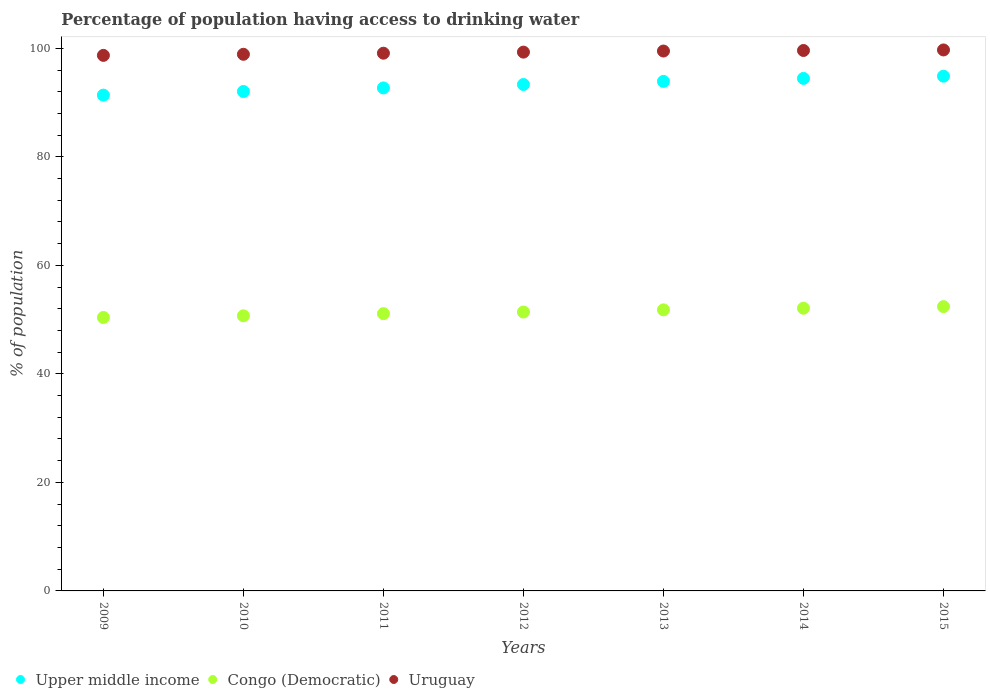How many different coloured dotlines are there?
Provide a short and direct response. 3. Is the number of dotlines equal to the number of legend labels?
Provide a short and direct response. Yes. What is the percentage of population having access to drinking water in Congo (Democratic) in 2009?
Your response must be concise. 50.4. Across all years, what is the maximum percentage of population having access to drinking water in Uruguay?
Make the answer very short. 99.7. Across all years, what is the minimum percentage of population having access to drinking water in Congo (Democratic)?
Offer a very short reply. 50.4. In which year was the percentage of population having access to drinking water in Upper middle income maximum?
Ensure brevity in your answer.  2015. In which year was the percentage of population having access to drinking water in Uruguay minimum?
Provide a succinct answer. 2009. What is the total percentage of population having access to drinking water in Congo (Democratic) in the graph?
Ensure brevity in your answer.  359.9. What is the difference between the percentage of population having access to drinking water in Congo (Democratic) in 2009 and that in 2013?
Give a very brief answer. -1.4. What is the difference between the percentage of population having access to drinking water in Congo (Democratic) in 2012 and the percentage of population having access to drinking water in Uruguay in 2009?
Ensure brevity in your answer.  -47.3. What is the average percentage of population having access to drinking water in Congo (Democratic) per year?
Provide a succinct answer. 51.41. In the year 2015, what is the difference between the percentage of population having access to drinking water in Uruguay and percentage of population having access to drinking water in Congo (Democratic)?
Provide a succinct answer. 47.3. What is the ratio of the percentage of population having access to drinking water in Uruguay in 2013 to that in 2014?
Give a very brief answer. 1. Is the percentage of population having access to drinking water in Upper middle income in 2011 less than that in 2015?
Make the answer very short. Yes. Is the difference between the percentage of population having access to drinking water in Uruguay in 2010 and 2015 greater than the difference between the percentage of population having access to drinking water in Congo (Democratic) in 2010 and 2015?
Offer a terse response. Yes. What is the difference between the highest and the second highest percentage of population having access to drinking water in Upper middle income?
Give a very brief answer. 0.41. What is the difference between the highest and the lowest percentage of population having access to drinking water in Congo (Democratic)?
Your answer should be compact. 2. In how many years, is the percentage of population having access to drinking water in Upper middle income greater than the average percentage of population having access to drinking water in Upper middle income taken over all years?
Provide a succinct answer. 4. Is it the case that in every year, the sum of the percentage of population having access to drinking water in Upper middle income and percentage of population having access to drinking water in Uruguay  is greater than the percentage of population having access to drinking water in Congo (Democratic)?
Your response must be concise. Yes. Is the percentage of population having access to drinking water in Upper middle income strictly greater than the percentage of population having access to drinking water in Congo (Democratic) over the years?
Keep it short and to the point. Yes. How many dotlines are there?
Your answer should be compact. 3. How many years are there in the graph?
Make the answer very short. 7. Are the values on the major ticks of Y-axis written in scientific E-notation?
Keep it short and to the point. No. How are the legend labels stacked?
Ensure brevity in your answer.  Horizontal. What is the title of the graph?
Ensure brevity in your answer.  Percentage of population having access to drinking water. Does "Paraguay" appear as one of the legend labels in the graph?
Your answer should be compact. No. What is the label or title of the Y-axis?
Your answer should be compact. % of population. What is the % of population of Upper middle income in 2009?
Provide a short and direct response. 91.38. What is the % of population of Congo (Democratic) in 2009?
Make the answer very short. 50.4. What is the % of population in Uruguay in 2009?
Make the answer very short. 98.7. What is the % of population in Upper middle income in 2010?
Provide a succinct answer. 92.04. What is the % of population in Congo (Democratic) in 2010?
Give a very brief answer. 50.7. What is the % of population of Uruguay in 2010?
Offer a very short reply. 98.9. What is the % of population in Upper middle income in 2011?
Ensure brevity in your answer.  92.7. What is the % of population in Congo (Democratic) in 2011?
Give a very brief answer. 51.1. What is the % of population of Uruguay in 2011?
Your answer should be very brief. 99.1. What is the % of population of Upper middle income in 2012?
Provide a short and direct response. 93.33. What is the % of population in Congo (Democratic) in 2012?
Ensure brevity in your answer.  51.4. What is the % of population of Uruguay in 2012?
Provide a succinct answer. 99.3. What is the % of population of Upper middle income in 2013?
Give a very brief answer. 93.91. What is the % of population in Congo (Democratic) in 2013?
Your response must be concise. 51.8. What is the % of population of Uruguay in 2013?
Provide a short and direct response. 99.5. What is the % of population in Upper middle income in 2014?
Make the answer very short. 94.45. What is the % of population in Congo (Democratic) in 2014?
Ensure brevity in your answer.  52.1. What is the % of population of Uruguay in 2014?
Give a very brief answer. 99.6. What is the % of population in Upper middle income in 2015?
Ensure brevity in your answer.  94.87. What is the % of population of Congo (Democratic) in 2015?
Offer a terse response. 52.4. What is the % of population in Uruguay in 2015?
Your answer should be compact. 99.7. Across all years, what is the maximum % of population in Upper middle income?
Your answer should be very brief. 94.87. Across all years, what is the maximum % of population in Congo (Democratic)?
Provide a short and direct response. 52.4. Across all years, what is the maximum % of population of Uruguay?
Offer a terse response. 99.7. Across all years, what is the minimum % of population in Upper middle income?
Provide a succinct answer. 91.38. Across all years, what is the minimum % of population in Congo (Democratic)?
Provide a short and direct response. 50.4. Across all years, what is the minimum % of population in Uruguay?
Your response must be concise. 98.7. What is the total % of population in Upper middle income in the graph?
Offer a very short reply. 652.68. What is the total % of population of Congo (Democratic) in the graph?
Offer a terse response. 359.9. What is the total % of population in Uruguay in the graph?
Your answer should be compact. 694.8. What is the difference between the % of population of Upper middle income in 2009 and that in 2010?
Provide a short and direct response. -0.67. What is the difference between the % of population of Upper middle income in 2009 and that in 2011?
Offer a very short reply. -1.32. What is the difference between the % of population of Upper middle income in 2009 and that in 2012?
Offer a terse response. -1.96. What is the difference between the % of population in Uruguay in 2009 and that in 2012?
Keep it short and to the point. -0.6. What is the difference between the % of population in Upper middle income in 2009 and that in 2013?
Ensure brevity in your answer.  -2.53. What is the difference between the % of population of Congo (Democratic) in 2009 and that in 2013?
Provide a succinct answer. -1.4. What is the difference between the % of population of Uruguay in 2009 and that in 2013?
Keep it short and to the point. -0.8. What is the difference between the % of population in Upper middle income in 2009 and that in 2014?
Your response must be concise. -3.08. What is the difference between the % of population of Upper middle income in 2009 and that in 2015?
Your response must be concise. -3.49. What is the difference between the % of population in Upper middle income in 2010 and that in 2011?
Your answer should be compact. -0.65. What is the difference between the % of population of Congo (Democratic) in 2010 and that in 2011?
Your answer should be very brief. -0.4. What is the difference between the % of population of Uruguay in 2010 and that in 2011?
Offer a very short reply. -0.2. What is the difference between the % of population of Upper middle income in 2010 and that in 2012?
Provide a short and direct response. -1.29. What is the difference between the % of population in Congo (Democratic) in 2010 and that in 2012?
Your answer should be very brief. -0.7. What is the difference between the % of population of Upper middle income in 2010 and that in 2013?
Offer a terse response. -1.86. What is the difference between the % of population of Upper middle income in 2010 and that in 2014?
Your answer should be compact. -2.41. What is the difference between the % of population in Upper middle income in 2010 and that in 2015?
Your response must be concise. -2.82. What is the difference between the % of population of Upper middle income in 2011 and that in 2012?
Provide a short and direct response. -0.64. What is the difference between the % of population in Congo (Democratic) in 2011 and that in 2012?
Keep it short and to the point. -0.3. What is the difference between the % of population in Upper middle income in 2011 and that in 2013?
Make the answer very short. -1.21. What is the difference between the % of population in Congo (Democratic) in 2011 and that in 2013?
Offer a terse response. -0.7. What is the difference between the % of population in Uruguay in 2011 and that in 2013?
Provide a short and direct response. -0.4. What is the difference between the % of population in Upper middle income in 2011 and that in 2014?
Offer a terse response. -1.76. What is the difference between the % of population in Uruguay in 2011 and that in 2014?
Offer a very short reply. -0.5. What is the difference between the % of population of Upper middle income in 2011 and that in 2015?
Offer a very short reply. -2.17. What is the difference between the % of population of Congo (Democratic) in 2011 and that in 2015?
Offer a terse response. -1.3. What is the difference between the % of population of Uruguay in 2011 and that in 2015?
Keep it short and to the point. -0.6. What is the difference between the % of population in Upper middle income in 2012 and that in 2013?
Keep it short and to the point. -0.57. What is the difference between the % of population of Congo (Democratic) in 2012 and that in 2013?
Your response must be concise. -0.4. What is the difference between the % of population in Uruguay in 2012 and that in 2013?
Offer a very short reply. -0.2. What is the difference between the % of population of Upper middle income in 2012 and that in 2014?
Offer a very short reply. -1.12. What is the difference between the % of population of Uruguay in 2012 and that in 2014?
Offer a very short reply. -0.3. What is the difference between the % of population in Upper middle income in 2012 and that in 2015?
Offer a very short reply. -1.53. What is the difference between the % of population in Congo (Democratic) in 2012 and that in 2015?
Give a very brief answer. -1. What is the difference between the % of population in Upper middle income in 2013 and that in 2014?
Keep it short and to the point. -0.55. What is the difference between the % of population of Upper middle income in 2013 and that in 2015?
Provide a short and direct response. -0.96. What is the difference between the % of population in Congo (Democratic) in 2013 and that in 2015?
Offer a terse response. -0.6. What is the difference between the % of population in Uruguay in 2013 and that in 2015?
Offer a terse response. -0.2. What is the difference between the % of population of Upper middle income in 2014 and that in 2015?
Provide a succinct answer. -0.41. What is the difference between the % of population of Congo (Democratic) in 2014 and that in 2015?
Offer a terse response. -0.3. What is the difference between the % of population in Upper middle income in 2009 and the % of population in Congo (Democratic) in 2010?
Give a very brief answer. 40.68. What is the difference between the % of population of Upper middle income in 2009 and the % of population of Uruguay in 2010?
Provide a succinct answer. -7.52. What is the difference between the % of population of Congo (Democratic) in 2009 and the % of population of Uruguay in 2010?
Offer a very short reply. -48.5. What is the difference between the % of population of Upper middle income in 2009 and the % of population of Congo (Democratic) in 2011?
Make the answer very short. 40.28. What is the difference between the % of population of Upper middle income in 2009 and the % of population of Uruguay in 2011?
Keep it short and to the point. -7.72. What is the difference between the % of population of Congo (Democratic) in 2009 and the % of population of Uruguay in 2011?
Your answer should be very brief. -48.7. What is the difference between the % of population in Upper middle income in 2009 and the % of population in Congo (Democratic) in 2012?
Ensure brevity in your answer.  39.98. What is the difference between the % of population in Upper middle income in 2009 and the % of population in Uruguay in 2012?
Give a very brief answer. -7.92. What is the difference between the % of population of Congo (Democratic) in 2009 and the % of population of Uruguay in 2012?
Your response must be concise. -48.9. What is the difference between the % of population of Upper middle income in 2009 and the % of population of Congo (Democratic) in 2013?
Provide a short and direct response. 39.58. What is the difference between the % of population of Upper middle income in 2009 and the % of population of Uruguay in 2013?
Your answer should be very brief. -8.12. What is the difference between the % of population in Congo (Democratic) in 2009 and the % of population in Uruguay in 2013?
Give a very brief answer. -49.1. What is the difference between the % of population in Upper middle income in 2009 and the % of population in Congo (Democratic) in 2014?
Offer a terse response. 39.28. What is the difference between the % of population in Upper middle income in 2009 and the % of population in Uruguay in 2014?
Provide a short and direct response. -8.22. What is the difference between the % of population of Congo (Democratic) in 2009 and the % of population of Uruguay in 2014?
Your answer should be very brief. -49.2. What is the difference between the % of population in Upper middle income in 2009 and the % of population in Congo (Democratic) in 2015?
Ensure brevity in your answer.  38.98. What is the difference between the % of population in Upper middle income in 2009 and the % of population in Uruguay in 2015?
Give a very brief answer. -8.32. What is the difference between the % of population of Congo (Democratic) in 2009 and the % of population of Uruguay in 2015?
Your answer should be very brief. -49.3. What is the difference between the % of population of Upper middle income in 2010 and the % of population of Congo (Democratic) in 2011?
Your response must be concise. 40.94. What is the difference between the % of population in Upper middle income in 2010 and the % of population in Uruguay in 2011?
Your response must be concise. -7.06. What is the difference between the % of population of Congo (Democratic) in 2010 and the % of population of Uruguay in 2011?
Provide a short and direct response. -48.4. What is the difference between the % of population of Upper middle income in 2010 and the % of population of Congo (Democratic) in 2012?
Your answer should be very brief. 40.64. What is the difference between the % of population in Upper middle income in 2010 and the % of population in Uruguay in 2012?
Provide a succinct answer. -7.26. What is the difference between the % of population in Congo (Democratic) in 2010 and the % of population in Uruguay in 2012?
Give a very brief answer. -48.6. What is the difference between the % of population in Upper middle income in 2010 and the % of population in Congo (Democratic) in 2013?
Provide a succinct answer. 40.24. What is the difference between the % of population of Upper middle income in 2010 and the % of population of Uruguay in 2013?
Keep it short and to the point. -7.46. What is the difference between the % of population of Congo (Democratic) in 2010 and the % of population of Uruguay in 2013?
Your response must be concise. -48.8. What is the difference between the % of population in Upper middle income in 2010 and the % of population in Congo (Democratic) in 2014?
Your answer should be very brief. 39.94. What is the difference between the % of population in Upper middle income in 2010 and the % of population in Uruguay in 2014?
Offer a very short reply. -7.56. What is the difference between the % of population of Congo (Democratic) in 2010 and the % of population of Uruguay in 2014?
Make the answer very short. -48.9. What is the difference between the % of population in Upper middle income in 2010 and the % of population in Congo (Democratic) in 2015?
Provide a succinct answer. 39.64. What is the difference between the % of population in Upper middle income in 2010 and the % of population in Uruguay in 2015?
Offer a terse response. -7.66. What is the difference between the % of population of Congo (Democratic) in 2010 and the % of population of Uruguay in 2015?
Your answer should be compact. -49. What is the difference between the % of population in Upper middle income in 2011 and the % of population in Congo (Democratic) in 2012?
Offer a terse response. 41.3. What is the difference between the % of population of Upper middle income in 2011 and the % of population of Uruguay in 2012?
Provide a succinct answer. -6.6. What is the difference between the % of population of Congo (Democratic) in 2011 and the % of population of Uruguay in 2012?
Your answer should be very brief. -48.2. What is the difference between the % of population in Upper middle income in 2011 and the % of population in Congo (Democratic) in 2013?
Offer a terse response. 40.9. What is the difference between the % of population of Upper middle income in 2011 and the % of population of Uruguay in 2013?
Your response must be concise. -6.8. What is the difference between the % of population in Congo (Democratic) in 2011 and the % of population in Uruguay in 2013?
Make the answer very short. -48.4. What is the difference between the % of population of Upper middle income in 2011 and the % of population of Congo (Democratic) in 2014?
Your answer should be compact. 40.6. What is the difference between the % of population of Upper middle income in 2011 and the % of population of Uruguay in 2014?
Offer a terse response. -6.9. What is the difference between the % of population of Congo (Democratic) in 2011 and the % of population of Uruguay in 2014?
Offer a terse response. -48.5. What is the difference between the % of population of Upper middle income in 2011 and the % of population of Congo (Democratic) in 2015?
Your response must be concise. 40.3. What is the difference between the % of population of Upper middle income in 2011 and the % of population of Uruguay in 2015?
Provide a succinct answer. -7. What is the difference between the % of population in Congo (Democratic) in 2011 and the % of population in Uruguay in 2015?
Provide a short and direct response. -48.6. What is the difference between the % of population of Upper middle income in 2012 and the % of population of Congo (Democratic) in 2013?
Keep it short and to the point. 41.53. What is the difference between the % of population of Upper middle income in 2012 and the % of population of Uruguay in 2013?
Provide a short and direct response. -6.17. What is the difference between the % of population of Congo (Democratic) in 2012 and the % of population of Uruguay in 2013?
Provide a succinct answer. -48.1. What is the difference between the % of population of Upper middle income in 2012 and the % of population of Congo (Democratic) in 2014?
Your answer should be compact. 41.23. What is the difference between the % of population in Upper middle income in 2012 and the % of population in Uruguay in 2014?
Provide a succinct answer. -6.27. What is the difference between the % of population of Congo (Democratic) in 2012 and the % of population of Uruguay in 2014?
Give a very brief answer. -48.2. What is the difference between the % of population in Upper middle income in 2012 and the % of population in Congo (Democratic) in 2015?
Provide a short and direct response. 40.93. What is the difference between the % of population in Upper middle income in 2012 and the % of population in Uruguay in 2015?
Ensure brevity in your answer.  -6.37. What is the difference between the % of population of Congo (Democratic) in 2012 and the % of population of Uruguay in 2015?
Provide a succinct answer. -48.3. What is the difference between the % of population in Upper middle income in 2013 and the % of population in Congo (Democratic) in 2014?
Offer a very short reply. 41.81. What is the difference between the % of population of Upper middle income in 2013 and the % of population of Uruguay in 2014?
Keep it short and to the point. -5.69. What is the difference between the % of population in Congo (Democratic) in 2013 and the % of population in Uruguay in 2014?
Your response must be concise. -47.8. What is the difference between the % of population of Upper middle income in 2013 and the % of population of Congo (Democratic) in 2015?
Keep it short and to the point. 41.51. What is the difference between the % of population of Upper middle income in 2013 and the % of population of Uruguay in 2015?
Provide a succinct answer. -5.79. What is the difference between the % of population in Congo (Democratic) in 2013 and the % of population in Uruguay in 2015?
Provide a short and direct response. -47.9. What is the difference between the % of population of Upper middle income in 2014 and the % of population of Congo (Democratic) in 2015?
Provide a succinct answer. 42.05. What is the difference between the % of population of Upper middle income in 2014 and the % of population of Uruguay in 2015?
Make the answer very short. -5.25. What is the difference between the % of population in Congo (Democratic) in 2014 and the % of population in Uruguay in 2015?
Give a very brief answer. -47.6. What is the average % of population of Upper middle income per year?
Make the answer very short. 93.24. What is the average % of population in Congo (Democratic) per year?
Your answer should be very brief. 51.41. What is the average % of population of Uruguay per year?
Provide a short and direct response. 99.26. In the year 2009, what is the difference between the % of population in Upper middle income and % of population in Congo (Democratic)?
Provide a succinct answer. 40.98. In the year 2009, what is the difference between the % of population in Upper middle income and % of population in Uruguay?
Ensure brevity in your answer.  -7.32. In the year 2009, what is the difference between the % of population of Congo (Democratic) and % of population of Uruguay?
Provide a short and direct response. -48.3. In the year 2010, what is the difference between the % of population in Upper middle income and % of population in Congo (Democratic)?
Keep it short and to the point. 41.34. In the year 2010, what is the difference between the % of population in Upper middle income and % of population in Uruguay?
Give a very brief answer. -6.86. In the year 2010, what is the difference between the % of population in Congo (Democratic) and % of population in Uruguay?
Your answer should be very brief. -48.2. In the year 2011, what is the difference between the % of population in Upper middle income and % of population in Congo (Democratic)?
Provide a succinct answer. 41.6. In the year 2011, what is the difference between the % of population of Upper middle income and % of population of Uruguay?
Provide a short and direct response. -6.4. In the year 2011, what is the difference between the % of population of Congo (Democratic) and % of population of Uruguay?
Your answer should be compact. -48. In the year 2012, what is the difference between the % of population of Upper middle income and % of population of Congo (Democratic)?
Provide a succinct answer. 41.93. In the year 2012, what is the difference between the % of population of Upper middle income and % of population of Uruguay?
Offer a terse response. -5.97. In the year 2012, what is the difference between the % of population of Congo (Democratic) and % of population of Uruguay?
Your response must be concise. -47.9. In the year 2013, what is the difference between the % of population in Upper middle income and % of population in Congo (Democratic)?
Your answer should be very brief. 42.11. In the year 2013, what is the difference between the % of population of Upper middle income and % of population of Uruguay?
Offer a terse response. -5.59. In the year 2013, what is the difference between the % of population of Congo (Democratic) and % of population of Uruguay?
Make the answer very short. -47.7. In the year 2014, what is the difference between the % of population of Upper middle income and % of population of Congo (Democratic)?
Offer a terse response. 42.35. In the year 2014, what is the difference between the % of population of Upper middle income and % of population of Uruguay?
Give a very brief answer. -5.15. In the year 2014, what is the difference between the % of population in Congo (Democratic) and % of population in Uruguay?
Give a very brief answer. -47.5. In the year 2015, what is the difference between the % of population of Upper middle income and % of population of Congo (Democratic)?
Give a very brief answer. 42.47. In the year 2015, what is the difference between the % of population of Upper middle income and % of population of Uruguay?
Give a very brief answer. -4.83. In the year 2015, what is the difference between the % of population in Congo (Democratic) and % of population in Uruguay?
Offer a terse response. -47.3. What is the ratio of the % of population of Congo (Democratic) in 2009 to that in 2010?
Offer a terse response. 0.99. What is the ratio of the % of population in Upper middle income in 2009 to that in 2011?
Provide a succinct answer. 0.99. What is the ratio of the % of population in Congo (Democratic) in 2009 to that in 2011?
Your answer should be very brief. 0.99. What is the ratio of the % of population of Uruguay in 2009 to that in 2011?
Your response must be concise. 1. What is the ratio of the % of population of Upper middle income in 2009 to that in 2012?
Provide a short and direct response. 0.98. What is the ratio of the % of population in Congo (Democratic) in 2009 to that in 2012?
Your response must be concise. 0.98. What is the ratio of the % of population in Upper middle income in 2009 to that in 2013?
Provide a succinct answer. 0.97. What is the ratio of the % of population in Congo (Democratic) in 2009 to that in 2013?
Your response must be concise. 0.97. What is the ratio of the % of population in Upper middle income in 2009 to that in 2014?
Offer a terse response. 0.97. What is the ratio of the % of population of Congo (Democratic) in 2009 to that in 2014?
Your response must be concise. 0.97. What is the ratio of the % of population of Uruguay in 2009 to that in 2014?
Your answer should be compact. 0.99. What is the ratio of the % of population of Upper middle income in 2009 to that in 2015?
Offer a very short reply. 0.96. What is the ratio of the % of population of Congo (Democratic) in 2009 to that in 2015?
Your answer should be very brief. 0.96. What is the ratio of the % of population of Congo (Democratic) in 2010 to that in 2011?
Your response must be concise. 0.99. What is the ratio of the % of population of Uruguay in 2010 to that in 2011?
Offer a very short reply. 1. What is the ratio of the % of population in Upper middle income in 2010 to that in 2012?
Your answer should be very brief. 0.99. What is the ratio of the % of population of Congo (Democratic) in 2010 to that in 2012?
Make the answer very short. 0.99. What is the ratio of the % of population of Uruguay in 2010 to that in 2012?
Provide a short and direct response. 1. What is the ratio of the % of population in Upper middle income in 2010 to that in 2013?
Provide a short and direct response. 0.98. What is the ratio of the % of population in Congo (Democratic) in 2010 to that in 2013?
Keep it short and to the point. 0.98. What is the ratio of the % of population of Upper middle income in 2010 to that in 2014?
Your answer should be very brief. 0.97. What is the ratio of the % of population of Congo (Democratic) in 2010 to that in 2014?
Your response must be concise. 0.97. What is the ratio of the % of population of Upper middle income in 2010 to that in 2015?
Offer a terse response. 0.97. What is the ratio of the % of population in Congo (Democratic) in 2010 to that in 2015?
Provide a succinct answer. 0.97. What is the ratio of the % of population in Uruguay in 2010 to that in 2015?
Your answer should be compact. 0.99. What is the ratio of the % of population of Congo (Democratic) in 2011 to that in 2012?
Provide a short and direct response. 0.99. What is the ratio of the % of population of Uruguay in 2011 to that in 2012?
Offer a very short reply. 1. What is the ratio of the % of population in Upper middle income in 2011 to that in 2013?
Provide a succinct answer. 0.99. What is the ratio of the % of population in Congo (Democratic) in 2011 to that in 2013?
Give a very brief answer. 0.99. What is the ratio of the % of population of Uruguay in 2011 to that in 2013?
Keep it short and to the point. 1. What is the ratio of the % of population in Upper middle income in 2011 to that in 2014?
Provide a succinct answer. 0.98. What is the ratio of the % of population in Congo (Democratic) in 2011 to that in 2014?
Keep it short and to the point. 0.98. What is the ratio of the % of population in Uruguay in 2011 to that in 2014?
Your response must be concise. 0.99. What is the ratio of the % of population of Upper middle income in 2011 to that in 2015?
Your answer should be very brief. 0.98. What is the ratio of the % of population of Congo (Democratic) in 2011 to that in 2015?
Give a very brief answer. 0.98. What is the ratio of the % of population in Uruguay in 2011 to that in 2015?
Provide a succinct answer. 0.99. What is the ratio of the % of population of Uruguay in 2012 to that in 2013?
Offer a very short reply. 1. What is the ratio of the % of population of Upper middle income in 2012 to that in 2014?
Your answer should be compact. 0.99. What is the ratio of the % of population in Congo (Democratic) in 2012 to that in 2014?
Give a very brief answer. 0.99. What is the ratio of the % of population of Uruguay in 2012 to that in 2014?
Ensure brevity in your answer.  1. What is the ratio of the % of population of Upper middle income in 2012 to that in 2015?
Give a very brief answer. 0.98. What is the ratio of the % of population in Congo (Democratic) in 2012 to that in 2015?
Give a very brief answer. 0.98. What is the ratio of the % of population of Uruguay in 2012 to that in 2015?
Your response must be concise. 1. What is the ratio of the % of population in Upper middle income in 2013 to that in 2014?
Provide a succinct answer. 0.99. What is the ratio of the % of population of Congo (Democratic) in 2013 to that in 2014?
Keep it short and to the point. 0.99. What is the ratio of the % of population in Upper middle income in 2013 to that in 2015?
Offer a terse response. 0.99. What is the ratio of the % of population of Uruguay in 2013 to that in 2015?
Keep it short and to the point. 1. What is the ratio of the % of population in Uruguay in 2014 to that in 2015?
Give a very brief answer. 1. What is the difference between the highest and the second highest % of population in Upper middle income?
Offer a terse response. 0.41. What is the difference between the highest and the lowest % of population of Upper middle income?
Provide a short and direct response. 3.49. What is the difference between the highest and the lowest % of population in Congo (Democratic)?
Ensure brevity in your answer.  2. 